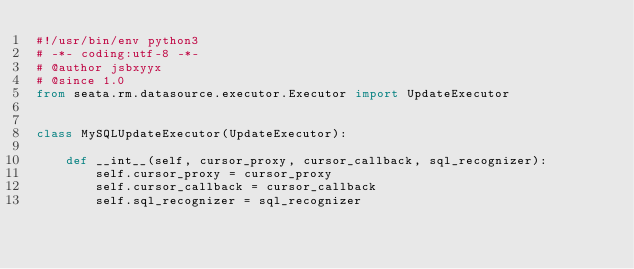<code> <loc_0><loc_0><loc_500><loc_500><_Python_>#!/usr/bin/env python3
# -*- coding:utf-8 -*-
# @author jsbxyyx
# @since 1.0
from seata.rm.datasource.executor.Executor import UpdateExecutor


class MySQLUpdateExecutor(UpdateExecutor):

    def __int__(self, cursor_proxy, cursor_callback, sql_recognizer):
        self.cursor_proxy = cursor_proxy
        self.cursor_callback = cursor_callback
        self.sql_recognizer = sql_recognizer
</code> 